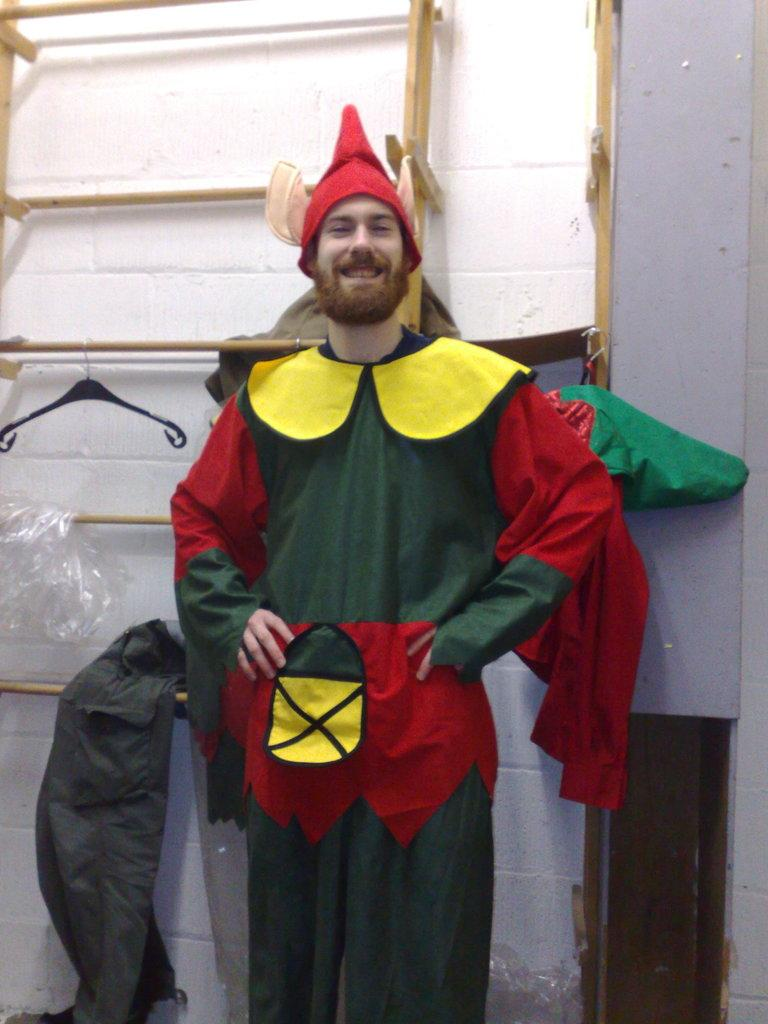What is the main subject of the image? The main subject of the image is a man. What is the man wearing in the image? The man is wearing a green and red color joker dress. What is the man's facial expression in the image? The man is smiling in the image. What is the man doing in the image? The man is giving a pose into the camera. What can be seen in the background of the image? There is a white wall and a wooden hanging cloth stand in the background of the image. What type of pets can be seen playing with the man in the image? There are no pets present in the image; it only features the man in a joker dress posing for the camera. 